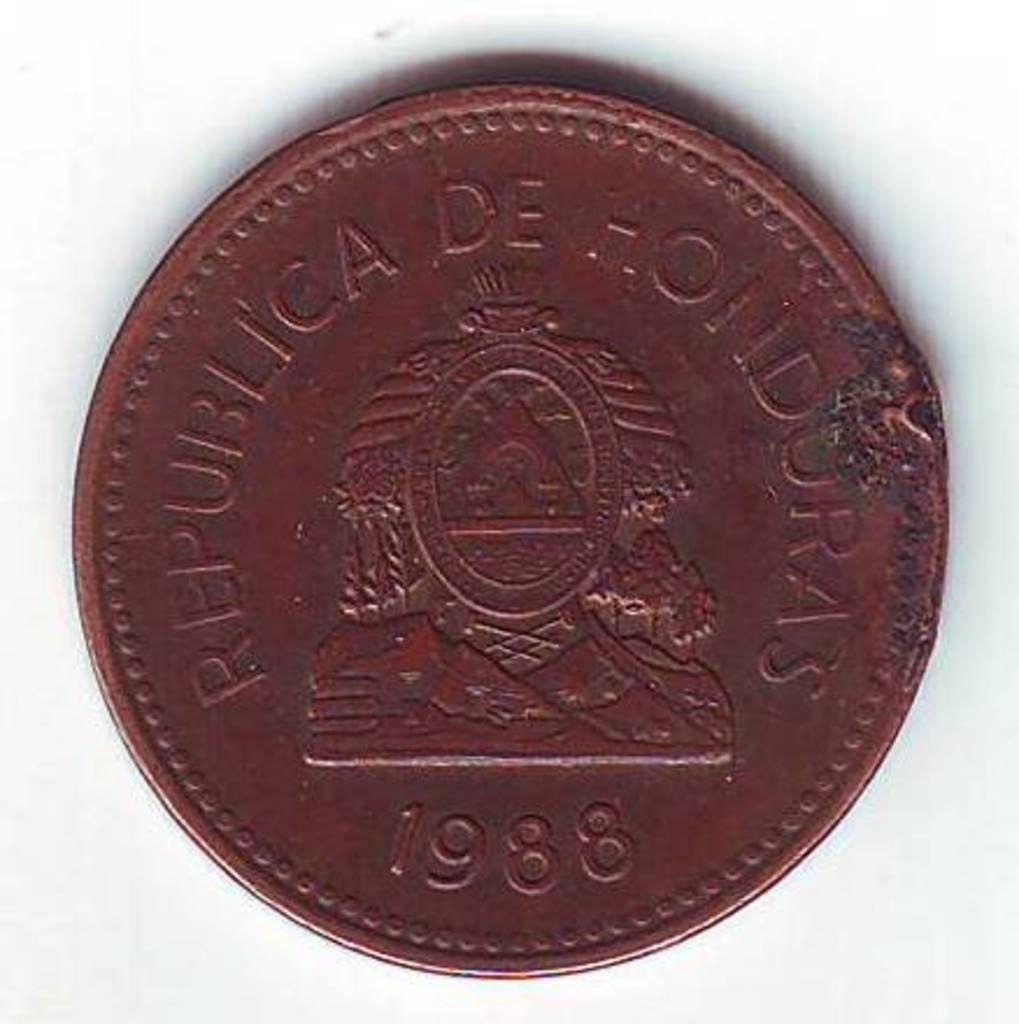<image>
Create a compact narrative representing the image presented. A coin from the Republica De Honduras and the year 1988 is displayed on a white back ground. 